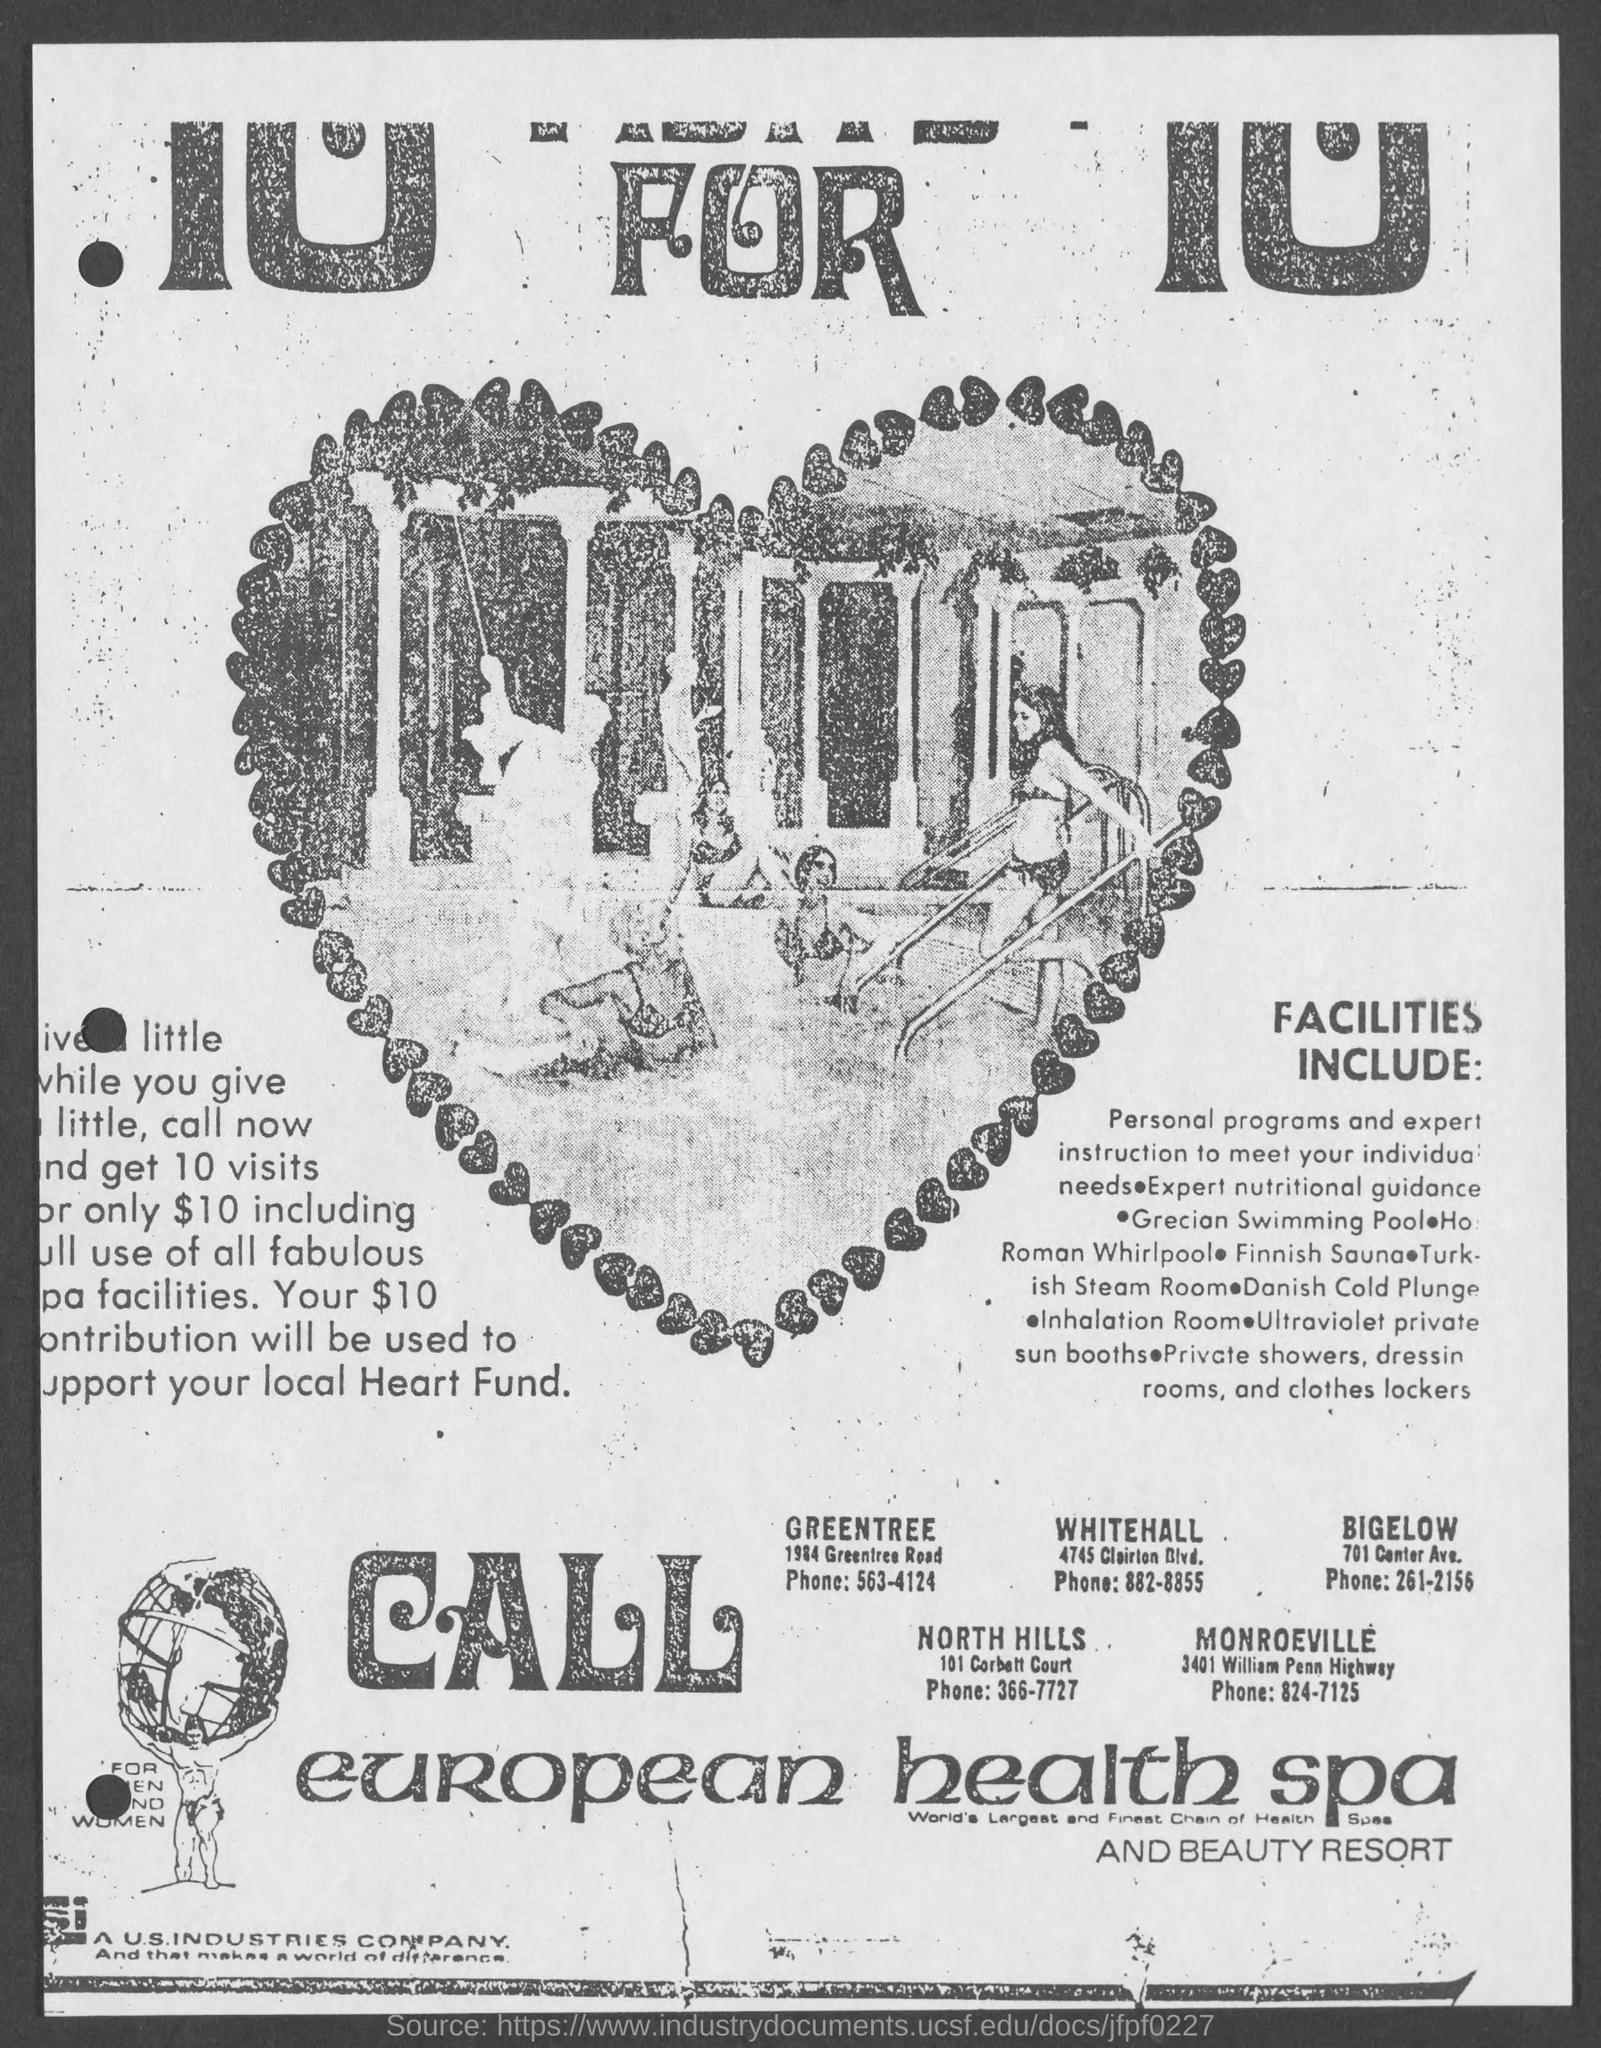What is the phone for Greentree?
Provide a succinct answer. 563-4124. What is the phone for Whitehall?
Keep it short and to the point. 882-8855. What is the phone for Bigelow?
Your answer should be very brief. 261-2156. What is the phone for North Hills?
Your answer should be compact. 366-7727. What is the phone for Monroeville?
Offer a very short reply. 824-7125. 